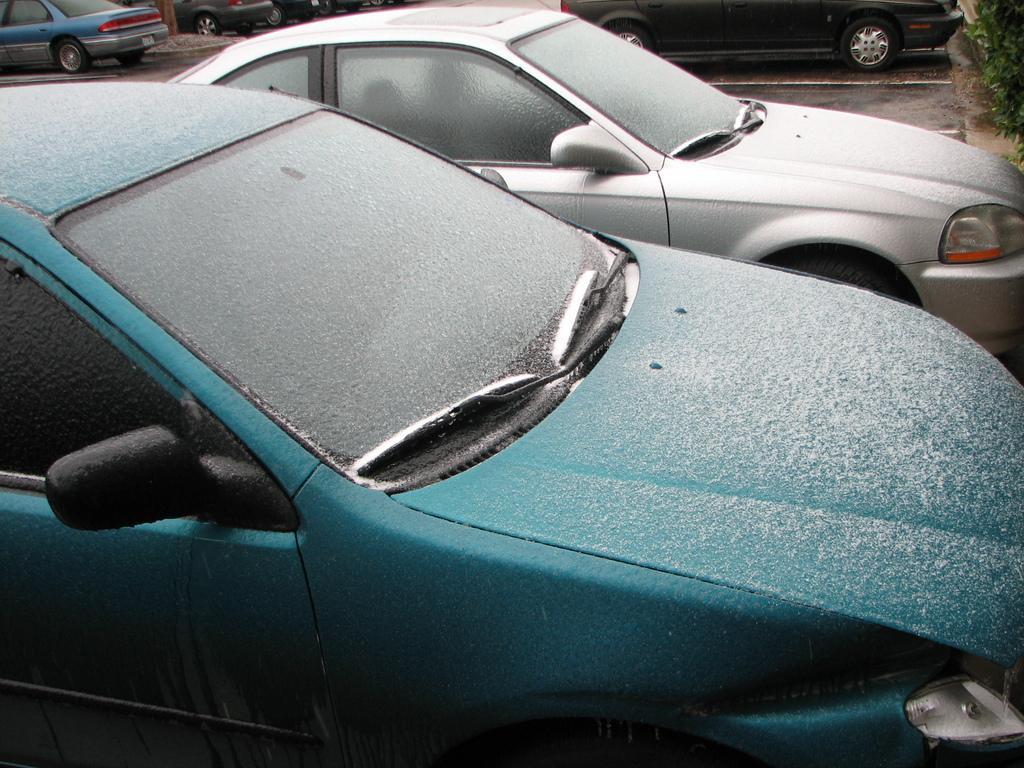In one or two sentences, can you explain what this image depicts? As we can see in the image there are cars here and there and on the right side background there are plants. 